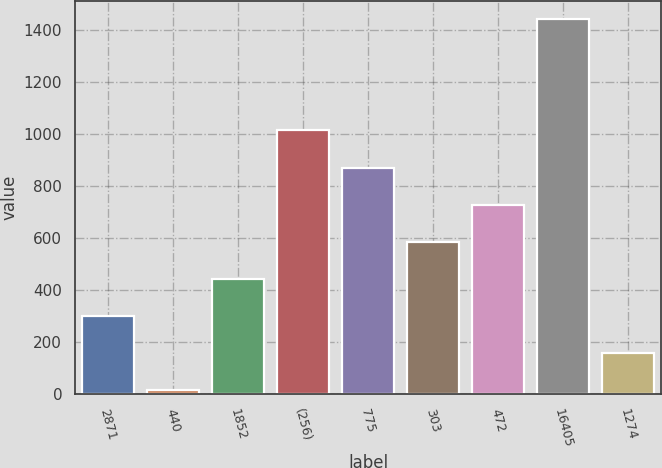<chart> <loc_0><loc_0><loc_500><loc_500><bar_chart><fcel>2871<fcel>440<fcel>1852<fcel>(256)<fcel>775<fcel>303<fcel>472<fcel>16405<fcel>1274<nl><fcel>300<fcel>15<fcel>442.5<fcel>1012.5<fcel>870<fcel>585<fcel>727.5<fcel>1440<fcel>157.5<nl></chart> 